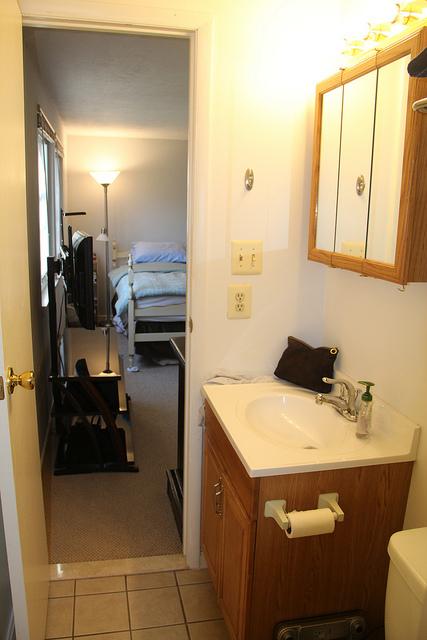Is the lamp turned on?
Short answer required. Yes. What color is the bathroom sink?
Be succinct. White. Is the door closed?
Quick response, please. No. 